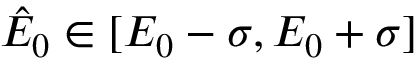<formula> <loc_0><loc_0><loc_500><loc_500>\hat { E } _ { 0 } \in [ E _ { 0 } - \sigma , E _ { 0 } + \sigma ]</formula> 